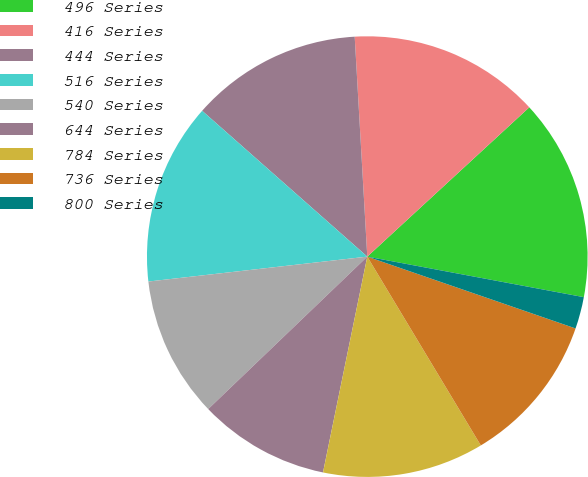Convert chart. <chart><loc_0><loc_0><loc_500><loc_500><pie_chart><fcel>496 Series<fcel>416 Series<fcel>444 Series<fcel>516 Series<fcel>540 Series<fcel>644 Series<fcel>784 Series<fcel>736 Series<fcel>800 Series<nl><fcel>14.8%<fcel>14.06%<fcel>12.58%<fcel>13.32%<fcel>10.36%<fcel>9.62%<fcel>11.84%<fcel>11.1%<fcel>2.34%<nl></chart> 